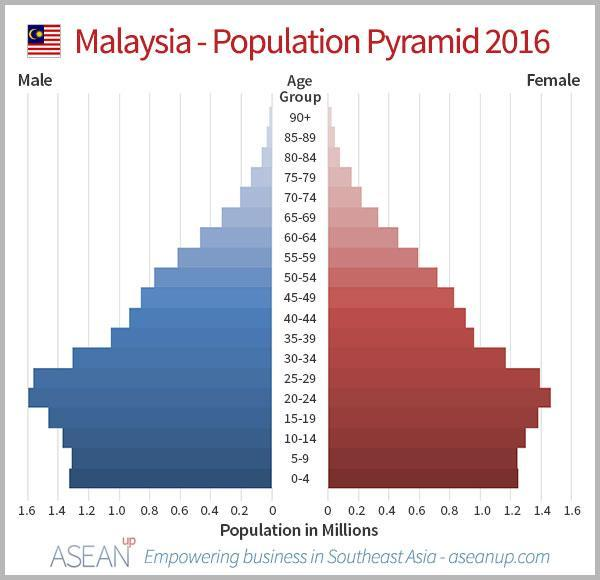How many age groups mentioned in this infographic?
Answer the question with a short phrase. 19 